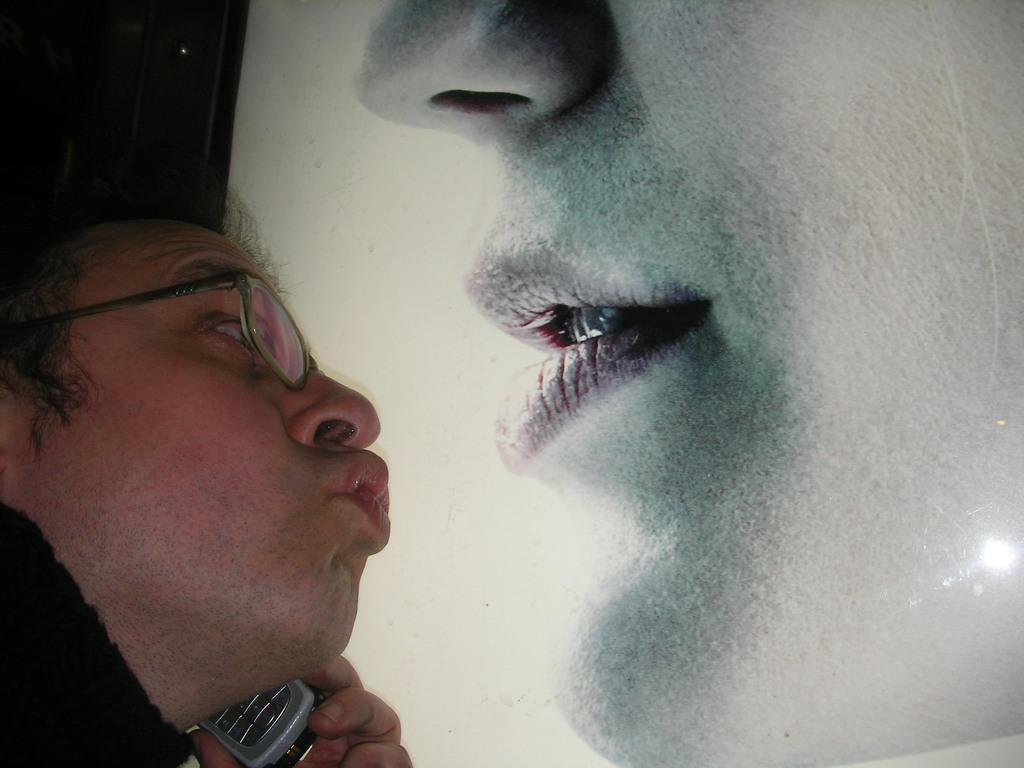What are the people in the image doing? The people in the image are sitting on the grass and playing musical instruments. What type of setting is depicted in the image? The setting is outdoors, with people sitting on the grass. Can you describe any objects or instruments visible in the image? The people are playing musical instruments, but there is no mention of a table or engine in the image. What song is the group playing on the table in the image? There is no table or song mentioned in the image; the group is playing musical instruments while sitting on the grass. 